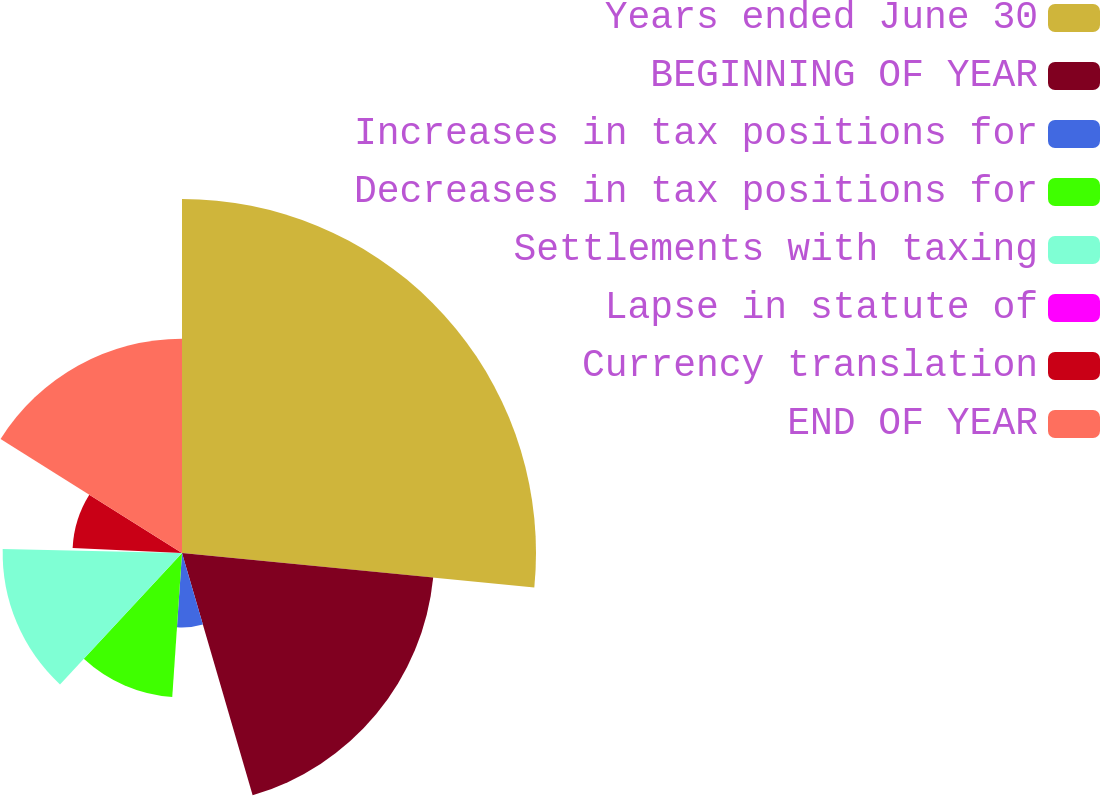Convert chart. <chart><loc_0><loc_0><loc_500><loc_500><pie_chart><fcel>Years ended June 30<fcel>BEGINNING OF YEAR<fcel>Increases in tax positions for<fcel>Decreases in tax positions for<fcel>Settlements with taxing<fcel>Lapse in statute of<fcel>Currency translation<fcel>END OF YEAR<nl><fcel>26.55%<fcel>18.93%<fcel>5.59%<fcel>10.83%<fcel>13.45%<fcel>0.36%<fcel>8.21%<fcel>16.07%<nl></chart> 